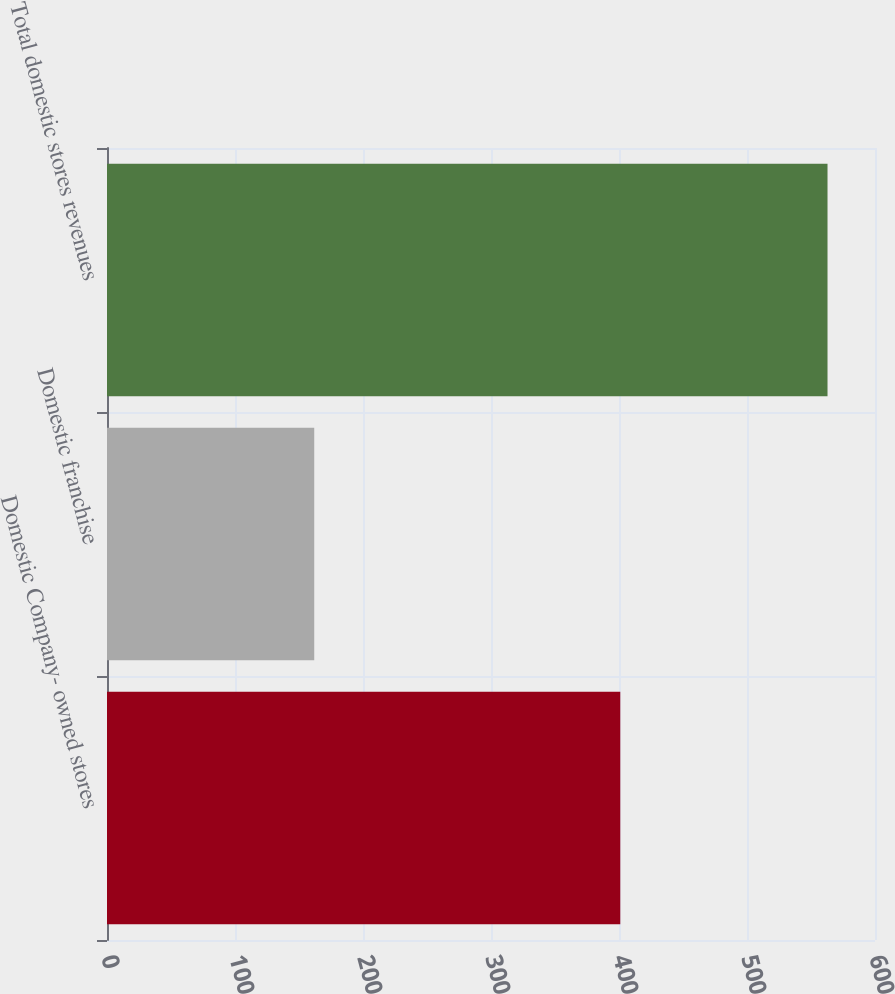Convert chart. <chart><loc_0><loc_0><loc_500><loc_500><bar_chart><fcel>Domestic Company- owned stores<fcel>Domestic franchise<fcel>Total domestic stores revenues<nl><fcel>401<fcel>161.9<fcel>562.9<nl></chart> 